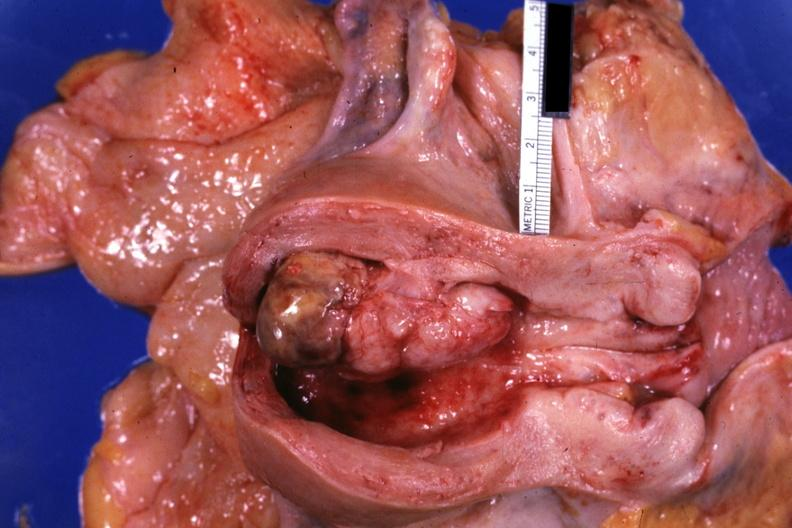s mixed mesodermal tumor present?
Answer the question using a single word or phrase. Yes 